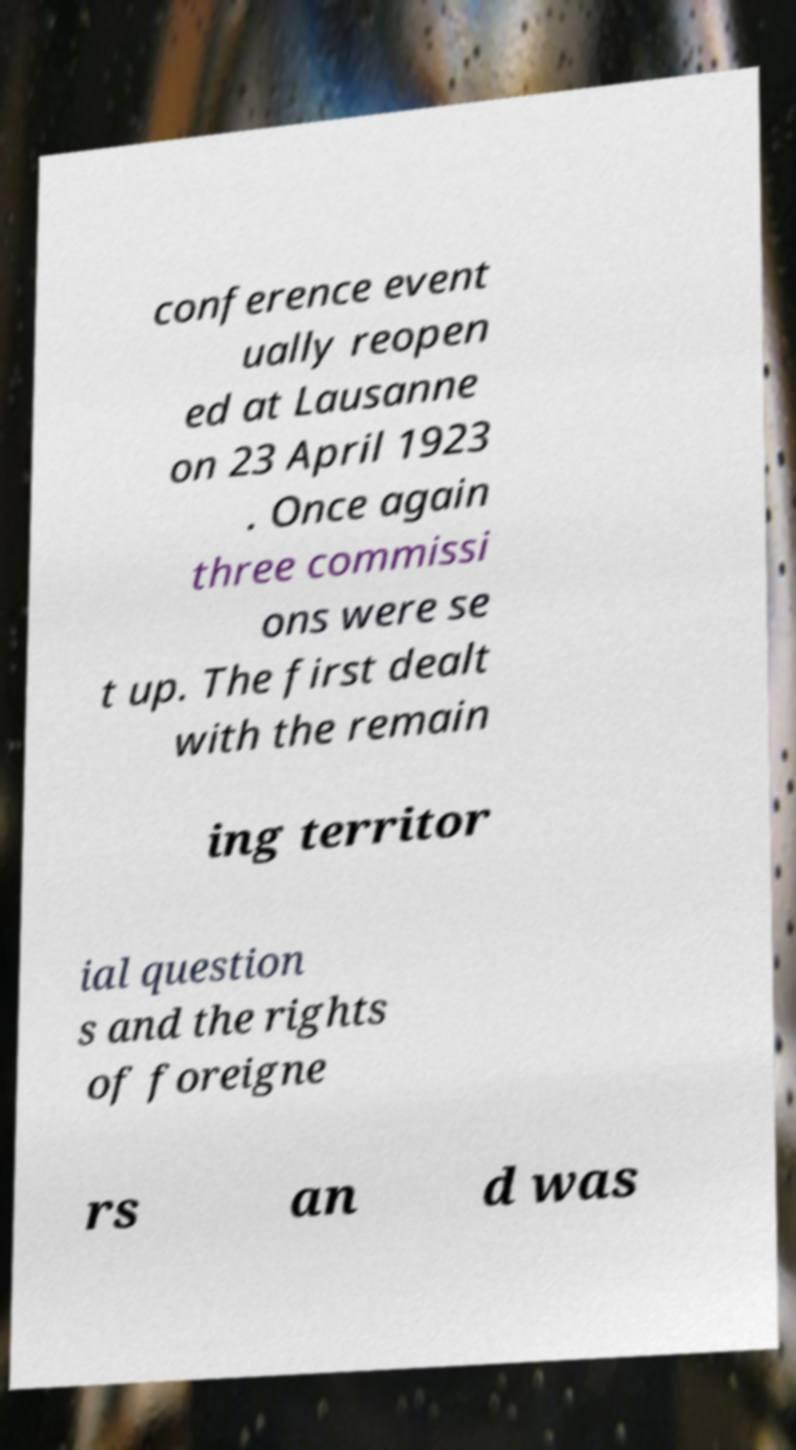Can you accurately transcribe the text from the provided image for me? conference event ually reopen ed at Lausanne on 23 April 1923 . Once again three commissi ons were se t up. The first dealt with the remain ing territor ial question s and the rights of foreigne rs an d was 